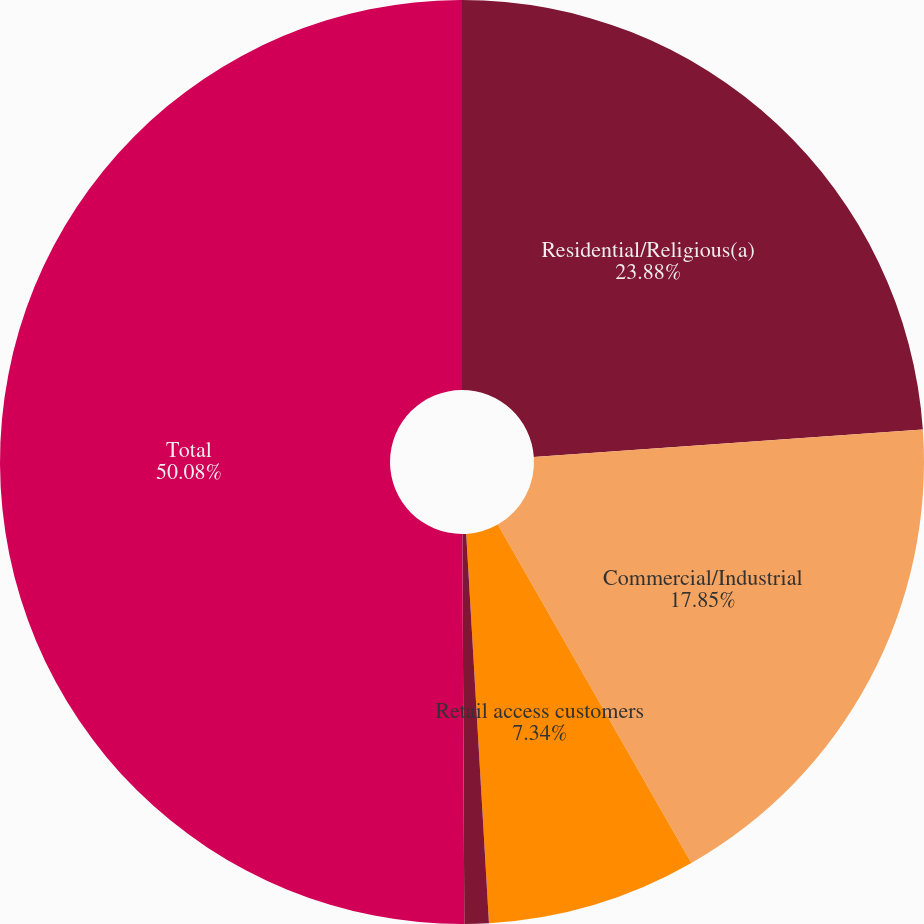<chart> <loc_0><loc_0><loc_500><loc_500><pie_chart><fcel>Residential/Religious(a)<fcel>Commercial/Industrial<fcel>Retail access customers<fcel>Public authorities<fcel>Total<nl><fcel>23.88%<fcel>17.85%<fcel>7.34%<fcel>0.85%<fcel>50.08%<nl></chart> 